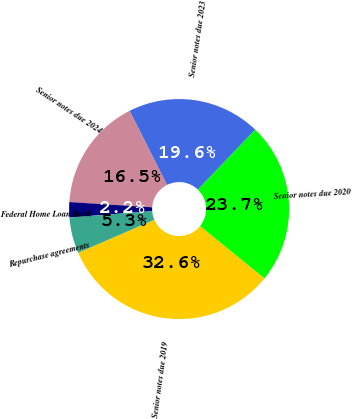<chart> <loc_0><loc_0><loc_500><loc_500><pie_chart><fcel>Senior notes due 2019<fcel>Senior notes due 2020<fcel>Senior notes due 2023<fcel>Senior notes due 2024<fcel>Federal Home Loan Bank<fcel>Repurchase agreements<nl><fcel>32.65%<fcel>23.7%<fcel>19.59%<fcel>16.55%<fcel>2.24%<fcel>5.28%<nl></chart> 